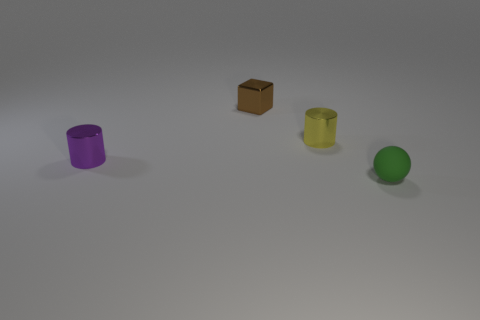Add 3 tiny green matte things. How many objects exist? 7 Subtract all balls. How many objects are left? 3 Subtract all yellow cylinders. How many cylinders are left? 1 Subtract 0 cyan cylinders. How many objects are left? 4 Subtract 1 spheres. How many spheres are left? 0 Subtract all cyan cubes. Subtract all blue cylinders. How many cubes are left? 1 Subtract all brown balls. How many yellow cylinders are left? 1 Subtract all small blue balls. Subtract all blocks. How many objects are left? 3 Add 3 purple objects. How many purple objects are left? 4 Add 1 tiny blue rubber spheres. How many tiny blue rubber spheres exist? 1 